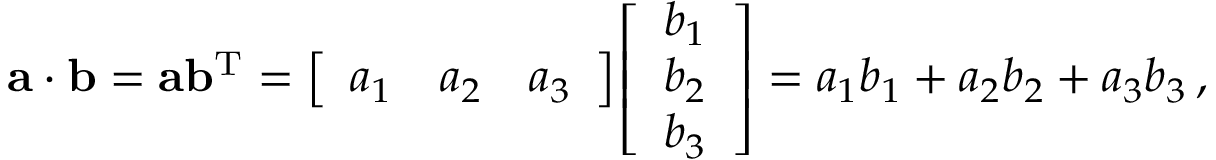<formula> <loc_0><loc_0><loc_500><loc_500>a \cdot b = a b ^ { T } = { \left [ \begin{array} { l l l } { a _ { 1 } } & { a _ { 2 } } & { a _ { 3 } } \end{array} \right ] } { \left [ \begin{array} { l } { b _ { 1 } } \\ { b _ { 2 } } \\ { b _ { 3 } } \end{array} \right ] } = a _ { 1 } b _ { 1 } + a _ { 2 } b _ { 2 } + a _ { 3 } b _ { 3 } \, ,</formula> 